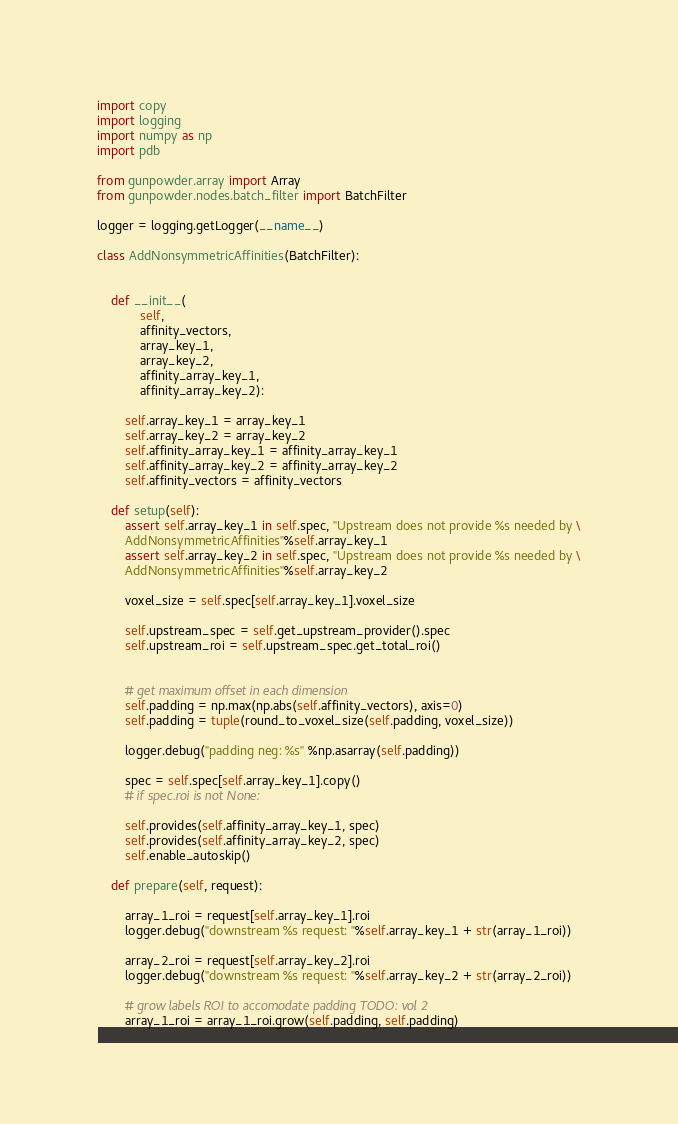Convert code to text. <code><loc_0><loc_0><loc_500><loc_500><_Python_>import copy
import logging
import numpy as np
import pdb

from gunpowder.array import Array
from gunpowder.nodes.batch_filter import BatchFilter

logger = logging.getLogger(__name__)

class AddNonsymmetricAffinities(BatchFilter):


    def __init__(
            self,
            affinity_vectors,
            array_key_1,
            array_key_2,
            affinity_array_key_1,
            affinity_array_key_2):

        self.array_key_1 = array_key_1
        self.array_key_2 = array_key_2
        self.affinity_array_key_1 = affinity_array_key_1
        self.affinity_array_key_2 = affinity_array_key_2
        self.affinity_vectors = affinity_vectors

    def setup(self):
        assert self.array_key_1 in self.spec, "Upstream does not provide %s needed by \
        AddNonsymmetricAffinities"%self.array_key_1
        assert self.array_key_2 in self.spec, "Upstream does not provide %s needed by \
        AddNonsymmetricAffinities"%self.array_key_2

        voxel_size = self.spec[self.array_key_1].voxel_size

        self.upstream_spec = self.get_upstream_provider().spec
        self.upstream_roi = self.upstream_spec.get_total_roi()


        # get maximum offset in each dimension
        self.padding = np.max(np.abs(self.affinity_vectors), axis=0)
        self.padding = tuple(round_to_voxel_size(self.padding, voxel_size))

        logger.debug("padding neg: %s" %np.asarray(self.padding))

        spec = self.spec[self.array_key_1].copy()
        # if spec.roi is not None:

        self.provides(self.affinity_array_key_1, spec)
        self.provides(self.affinity_array_key_2, spec)
        self.enable_autoskip()

    def prepare(self, request):

        array_1_roi = request[self.array_key_1].roi
        logger.debug("downstream %s request: "%self.array_key_1 + str(array_1_roi))

        array_2_roi = request[self.array_key_2].roi
        logger.debug("downstream %s request: "%self.array_key_2 + str(array_2_roi))

        # grow labels ROI to accomodate padding TODO: vol 2
        array_1_roi = array_1_roi.grow(self.padding, self.padding)</code> 